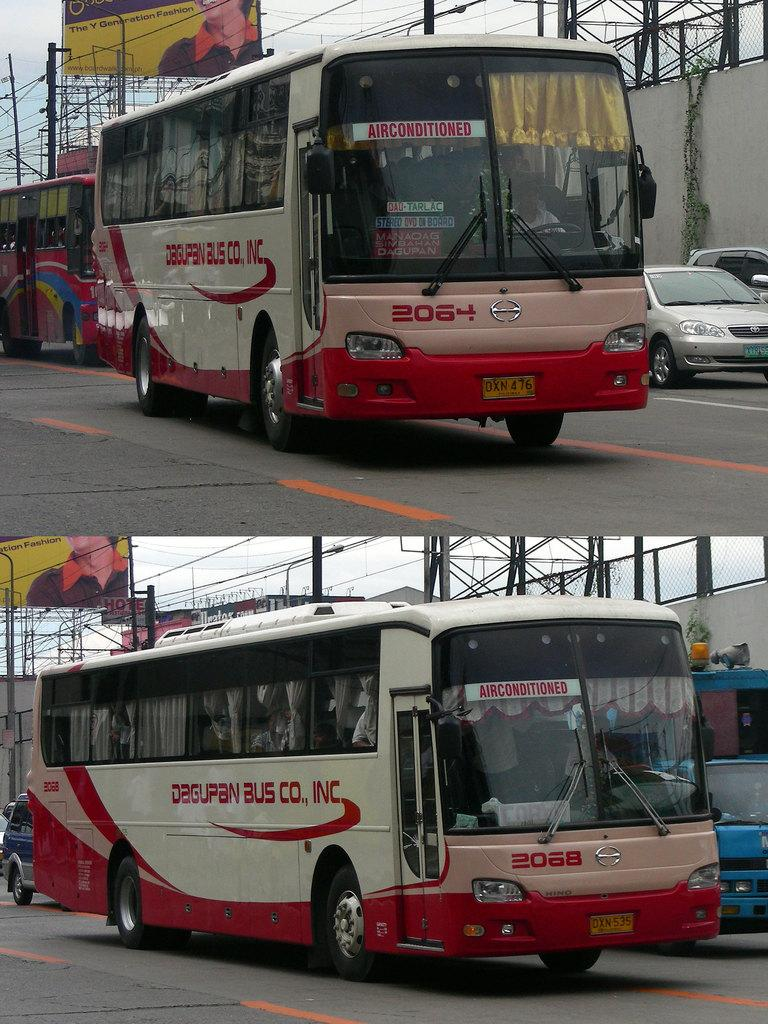What type of vehicles can be seen in the image? There are buses in the image. What else can be seen on the road in the image? There are vehicles on the road in the image. What is the background of the image? There is a wall in the image. What type of advertisements are present in the image? There are hoardings in the image. What structures can be seen in the image? There are rods in the image. What is the name of the bee that is sitting on the bus in the image? There are no bees present in the image, so it is not possible to determine the name of a bee. 